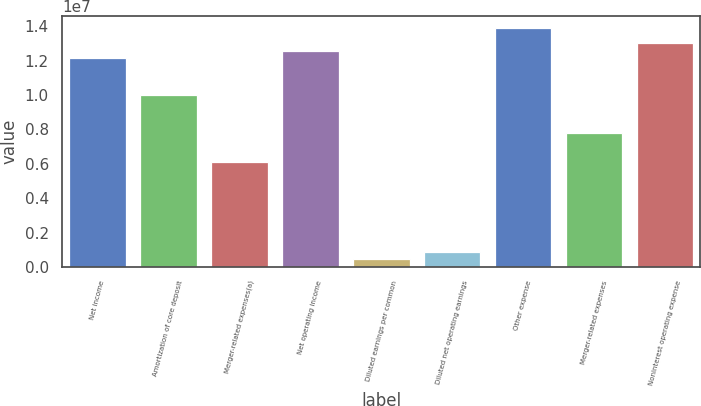Convert chart. <chart><loc_0><loc_0><loc_500><loc_500><bar_chart><fcel>Net income<fcel>Amortization of core deposit<fcel>Merger-related expenses(a)<fcel>Net operating income<fcel>Diluted earnings per common<fcel>Diluted net operating earnings<fcel>Other expense<fcel>Merger-related expenses<fcel>Noninterest operating expense<nl><fcel>1.2152e+07<fcel>9.98197e+06<fcel>6.07598e+06<fcel>1.2586e+07<fcel>434002<fcel>868000<fcel>1.3888e+07<fcel>7.81198e+06<fcel>1.302e+07<nl></chart> 